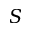Convert formula to latex. <formula><loc_0><loc_0><loc_500><loc_500>S</formula> 